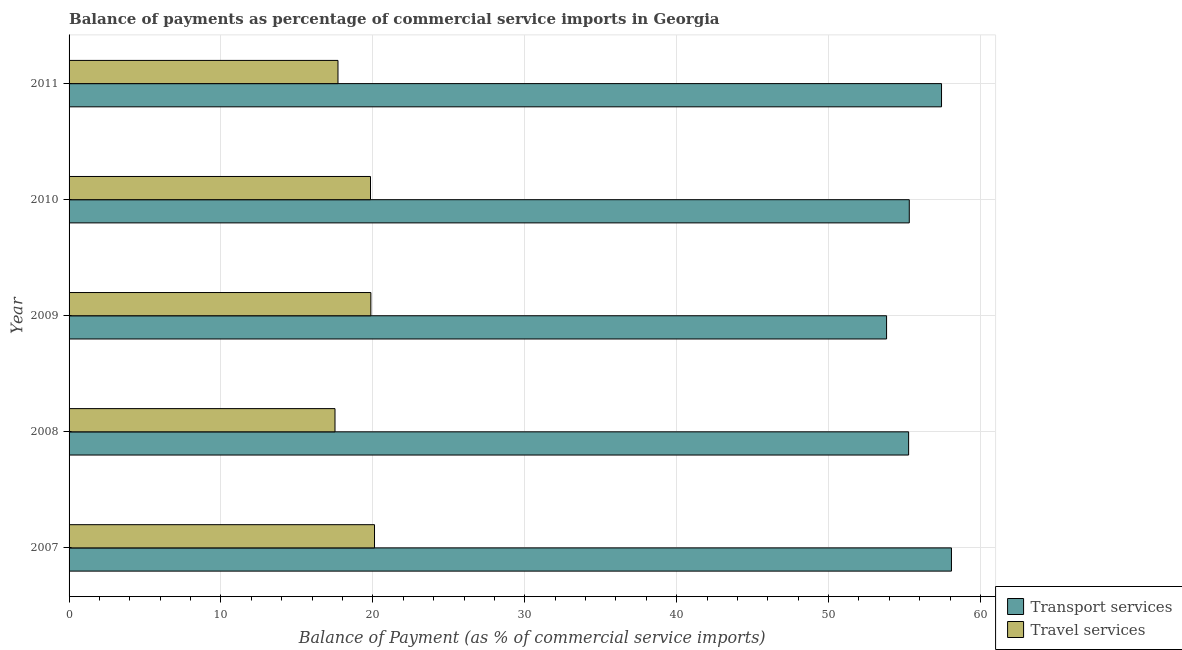How many groups of bars are there?
Your response must be concise. 5. Are the number of bars on each tick of the Y-axis equal?
Provide a succinct answer. Yes. In how many cases, is the number of bars for a given year not equal to the number of legend labels?
Provide a short and direct response. 0. What is the balance of payments of travel services in 2008?
Provide a succinct answer. 17.51. Across all years, what is the maximum balance of payments of travel services?
Your answer should be compact. 20.11. Across all years, what is the minimum balance of payments of transport services?
Keep it short and to the point. 53.82. In which year was the balance of payments of transport services minimum?
Give a very brief answer. 2009. What is the total balance of payments of transport services in the graph?
Keep it short and to the point. 279.92. What is the difference between the balance of payments of travel services in 2007 and that in 2010?
Your response must be concise. 0.27. What is the difference between the balance of payments of travel services in 2008 and the balance of payments of transport services in 2010?
Ensure brevity in your answer.  -37.81. What is the average balance of payments of transport services per year?
Offer a terse response. 55.98. In the year 2011, what is the difference between the balance of payments of travel services and balance of payments of transport services?
Keep it short and to the point. -39.73. Is the balance of payments of travel services in 2007 less than that in 2010?
Your response must be concise. No. What is the difference between the highest and the second highest balance of payments of transport services?
Provide a short and direct response. 0.65. Is the sum of the balance of payments of travel services in 2007 and 2010 greater than the maximum balance of payments of transport services across all years?
Make the answer very short. No. What does the 1st bar from the top in 2008 represents?
Your response must be concise. Travel services. What does the 1st bar from the bottom in 2008 represents?
Ensure brevity in your answer.  Transport services. How many years are there in the graph?
Your answer should be compact. 5. Are the values on the major ticks of X-axis written in scientific E-notation?
Offer a terse response. No. Does the graph contain any zero values?
Keep it short and to the point. No. Does the graph contain grids?
Provide a succinct answer. Yes. How many legend labels are there?
Provide a succinct answer. 2. What is the title of the graph?
Provide a short and direct response. Balance of payments as percentage of commercial service imports in Georgia. Does "Foreign liabilities" appear as one of the legend labels in the graph?
Keep it short and to the point. No. What is the label or title of the X-axis?
Your answer should be very brief. Balance of Payment (as % of commercial service imports). What is the Balance of Payment (as % of commercial service imports) of Transport services in 2007?
Give a very brief answer. 58.09. What is the Balance of Payment (as % of commercial service imports) in Travel services in 2007?
Provide a short and direct response. 20.11. What is the Balance of Payment (as % of commercial service imports) of Transport services in 2008?
Give a very brief answer. 55.27. What is the Balance of Payment (as % of commercial service imports) in Travel services in 2008?
Make the answer very short. 17.51. What is the Balance of Payment (as % of commercial service imports) of Transport services in 2009?
Your response must be concise. 53.82. What is the Balance of Payment (as % of commercial service imports) of Travel services in 2009?
Provide a short and direct response. 19.87. What is the Balance of Payment (as % of commercial service imports) of Transport services in 2010?
Ensure brevity in your answer.  55.31. What is the Balance of Payment (as % of commercial service imports) of Travel services in 2010?
Make the answer very short. 19.84. What is the Balance of Payment (as % of commercial service imports) of Transport services in 2011?
Give a very brief answer. 57.44. What is the Balance of Payment (as % of commercial service imports) of Travel services in 2011?
Provide a succinct answer. 17.7. Across all years, what is the maximum Balance of Payment (as % of commercial service imports) of Transport services?
Provide a succinct answer. 58.09. Across all years, what is the maximum Balance of Payment (as % of commercial service imports) in Travel services?
Provide a short and direct response. 20.11. Across all years, what is the minimum Balance of Payment (as % of commercial service imports) in Transport services?
Ensure brevity in your answer.  53.82. Across all years, what is the minimum Balance of Payment (as % of commercial service imports) in Travel services?
Give a very brief answer. 17.51. What is the total Balance of Payment (as % of commercial service imports) in Transport services in the graph?
Provide a succinct answer. 279.92. What is the total Balance of Payment (as % of commercial service imports) of Travel services in the graph?
Your answer should be very brief. 95.03. What is the difference between the Balance of Payment (as % of commercial service imports) in Transport services in 2007 and that in 2008?
Keep it short and to the point. 2.82. What is the difference between the Balance of Payment (as % of commercial service imports) of Travel services in 2007 and that in 2008?
Your response must be concise. 2.6. What is the difference between the Balance of Payment (as % of commercial service imports) in Transport services in 2007 and that in 2009?
Offer a terse response. 4.27. What is the difference between the Balance of Payment (as % of commercial service imports) of Travel services in 2007 and that in 2009?
Make the answer very short. 0.24. What is the difference between the Balance of Payment (as % of commercial service imports) of Transport services in 2007 and that in 2010?
Keep it short and to the point. 2.78. What is the difference between the Balance of Payment (as % of commercial service imports) of Travel services in 2007 and that in 2010?
Provide a succinct answer. 0.27. What is the difference between the Balance of Payment (as % of commercial service imports) in Transport services in 2007 and that in 2011?
Make the answer very short. 0.65. What is the difference between the Balance of Payment (as % of commercial service imports) of Travel services in 2007 and that in 2011?
Your response must be concise. 2.41. What is the difference between the Balance of Payment (as % of commercial service imports) of Transport services in 2008 and that in 2009?
Your answer should be very brief. 1.45. What is the difference between the Balance of Payment (as % of commercial service imports) in Travel services in 2008 and that in 2009?
Your response must be concise. -2.36. What is the difference between the Balance of Payment (as % of commercial service imports) in Transport services in 2008 and that in 2010?
Keep it short and to the point. -0.04. What is the difference between the Balance of Payment (as % of commercial service imports) in Travel services in 2008 and that in 2010?
Keep it short and to the point. -2.34. What is the difference between the Balance of Payment (as % of commercial service imports) in Transport services in 2008 and that in 2011?
Offer a very short reply. -2.17. What is the difference between the Balance of Payment (as % of commercial service imports) of Travel services in 2008 and that in 2011?
Offer a very short reply. -0.2. What is the difference between the Balance of Payment (as % of commercial service imports) of Transport services in 2009 and that in 2010?
Ensure brevity in your answer.  -1.49. What is the difference between the Balance of Payment (as % of commercial service imports) of Travel services in 2009 and that in 2010?
Provide a short and direct response. 0.02. What is the difference between the Balance of Payment (as % of commercial service imports) in Transport services in 2009 and that in 2011?
Your answer should be compact. -3.62. What is the difference between the Balance of Payment (as % of commercial service imports) of Travel services in 2009 and that in 2011?
Provide a short and direct response. 2.16. What is the difference between the Balance of Payment (as % of commercial service imports) of Transport services in 2010 and that in 2011?
Provide a succinct answer. -2.12. What is the difference between the Balance of Payment (as % of commercial service imports) of Travel services in 2010 and that in 2011?
Provide a short and direct response. 2.14. What is the difference between the Balance of Payment (as % of commercial service imports) of Transport services in 2007 and the Balance of Payment (as % of commercial service imports) of Travel services in 2008?
Provide a short and direct response. 40.58. What is the difference between the Balance of Payment (as % of commercial service imports) in Transport services in 2007 and the Balance of Payment (as % of commercial service imports) in Travel services in 2009?
Keep it short and to the point. 38.22. What is the difference between the Balance of Payment (as % of commercial service imports) in Transport services in 2007 and the Balance of Payment (as % of commercial service imports) in Travel services in 2010?
Provide a short and direct response. 38.24. What is the difference between the Balance of Payment (as % of commercial service imports) in Transport services in 2007 and the Balance of Payment (as % of commercial service imports) in Travel services in 2011?
Your answer should be very brief. 40.39. What is the difference between the Balance of Payment (as % of commercial service imports) of Transport services in 2008 and the Balance of Payment (as % of commercial service imports) of Travel services in 2009?
Provide a succinct answer. 35.4. What is the difference between the Balance of Payment (as % of commercial service imports) of Transport services in 2008 and the Balance of Payment (as % of commercial service imports) of Travel services in 2010?
Keep it short and to the point. 35.43. What is the difference between the Balance of Payment (as % of commercial service imports) in Transport services in 2008 and the Balance of Payment (as % of commercial service imports) in Travel services in 2011?
Provide a succinct answer. 37.57. What is the difference between the Balance of Payment (as % of commercial service imports) of Transport services in 2009 and the Balance of Payment (as % of commercial service imports) of Travel services in 2010?
Provide a short and direct response. 33.97. What is the difference between the Balance of Payment (as % of commercial service imports) in Transport services in 2009 and the Balance of Payment (as % of commercial service imports) in Travel services in 2011?
Your answer should be very brief. 36.12. What is the difference between the Balance of Payment (as % of commercial service imports) in Transport services in 2010 and the Balance of Payment (as % of commercial service imports) in Travel services in 2011?
Keep it short and to the point. 37.61. What is the average Balance of Payment (as % of commercial service imports) in Transport services per year?
Make the answer very short. 55.98. What is the average Balance of Payment (as % of commercial service imports) of Travel services per year?
Make the answer very short. 19.01. In the year 2007, what is the difference between the Balance of Payment (as % of commercial service imports) of Transport services and Balance of Payment (as % of commercial service imports) of Travel services?
Make the answer very short. 37.98. In the year 2008, what is the difference between the Balance of Payment (as % of commercial service imports) in Transport services and Balance of Payment (as % of commercial service imports) in Travel services?
Offer a very short reply. 37.76. In the year 2009, what is the difference between the Balance of Payment (as % of commercial service imports) in Transport services and Balance of Payment (as % of commercial service imports) in Travel services?
Offer a very short reply. 33.95. In the year 2010, what is the difference between the Balance of Payment (as % of commercial service imports) in Transport services and Balance of Payment (as % of commercial service imports) in Travel services?
Your response must be concise. 35.47. In the year 2011, what is the difference between the Balance of Payment (as % of commercial service imports) of Transport services and Balance of Payment (as % of commercial service imports) of Travel services?
Ensure brevity in your answer.  39.73. What is the ratio of the Balance of Payment (as % of commercial service imports) of Transport services in 2007 to that in 2008?
Offer a terse response. 1.05. What is the ratio of the Balance of Payment (as % of commercial service imports) in Travel services in 2007 to that in 2008?
Provide a short and direct response. 1.15. What is the ratio of the Balance of Payment (as % of commercial service imports) of Transport services in 2007 to that in 2009?
Make the answer very short. 1.08. What is the ratio of the Balance of Payment (as % of commercial service imports) in Travel services in 2007 to that in 2009?
Your response must be concise. 1.01. What is the ratio of the Balance of Payment (as % of commercial service imports) of Transport services in 2007 to that in 2010?
Give a very brief answer. 1.05. What is the ratio of the Balance of Payment (as % of commercial service imports) in Travel services in 2007 to that in 2010?
Give a very brief answer. 1.01. What is the ratio of the Balance of Payment (as % of commercial service imports) of Transport services in 2007 to that in 2011?
Give a very brief answer. 1.01. What is the ratio of the Balance of Payment (as % of commercial service imports) of Travel services in 2007 to that in 2011?
Your answer should be compact. 1.14. What is the ratio of the Balance of Payment (as % of commercial service imports) of Transport services in 2008 to that in 2009?
Provide a short and direct response. 1.03. What is the ratio of the Balance of Payment (as % of commercial service imports) in Travel services in 2008 to that in 2009?
Make the answer very short. 0.88. What is the ratio of the Balance of Payment (as % of commercial service imports) in Transport services in 2008 to that in 2010?
Provide a short and direct response. 1. What is the ratio of the Balance of Payment (as % of commercial service imports) of Travel services in 2008 to that in 2010?
Your response must be concise. 0.88. What is the ratio of the Balance of Payment (as % of commercial service imports) in Transport services in 2008 to that in 2011?
Keep it short and to the point. 0.96. What is the ratio of the Balance of Payment (as % of commercial service imports) in Travel services in 2008 to that in 2011?
Ensure brevity in your answer.  0.99. What is the ratio of the Balance of Payment (as % of commercial service imports) in Transport services in 2009 to that in 2011?
Your response must be concise. 0.94. What is the ratio of the Balance of Payment (as % of commercial service imports) of Travel services in 2009 to that in 2011?
Keep it short and to the point. 1.12. What is the ratio of the Balance of Payment (as % of commercial service imports) in Transport services in 2010 to that in 2011?
Make the answer very short. 0.96. What is the ratio of the Balance of Payment (as % of commercial service imports) of Travel services in 2010 to that in 2011?
Your answer should be very brief. 1.12. What is the difference between the highest and the second highest Balance of Payment (as % of commercial service imports) of Transport services?
Offer a terse response. 0.65. What is the difference between the highest and the second highest Balance of Payment (as % of commercial service imports) of Travel services?
Give a very brief answer. 0.24. What is the difference between the highest and the lowest Balance of Payment (as % of commercial service imports) in Transport services?
Provide a succinct answer. 4.27. What is the difference between the highest and the lowest Balance of Payment (as % of commercial service imports) in Travel services?
Keep it short and to the point. 2.6. 